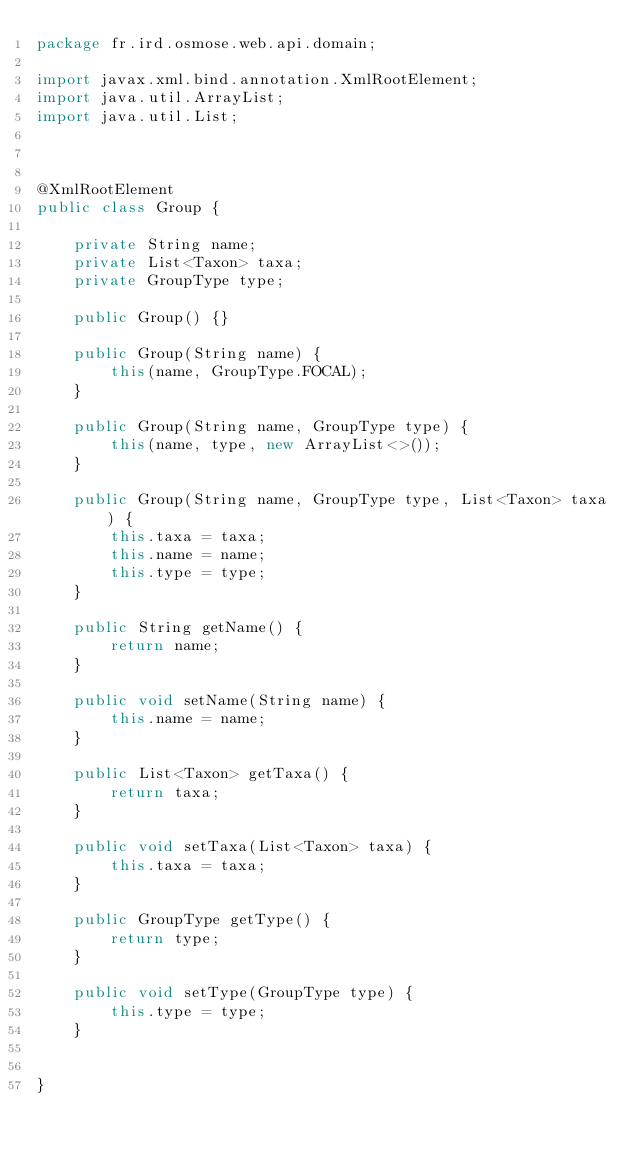Convert code to text. <code><loc_0><loc_0><loc_500><loc_500><_Java_>package fr.ird.osmose.web.api.domain;

import javax.xml.bind.annotation.XmlRootElement;
import java.util.ArrayList;
import java.util.List;



@XmlRootElement
public class Group {

    private String name;
    private List<Taxon> taxa;
    private GroupType type;

    public Group() {}

    public Group(String name) {
        this(name, GroupType.FOCAL);
    }

    public Group(String name, GroupType type) {
        this(name, type, new ArrayList<>());
    }

    public Group(String name, GroupType type, List<Taxon> taxa) {
        this.taxa = taxa;
        this.name = name;
        this.type = type;
    }

    public String getName() {
        return name;
    }

    public void setName(String name) {
        this.name = name;
    }

    public List<Taxon> getTaxa() {
        return taxa;
    }

    public void setTaxa(List<Taxon> taxa) {
        this.taxa = taxa;
    }

    public GroupType getType() {
        return type;
    }

    public void setType(GroupType type) {
        this.type = type;
    }


}
</code> 